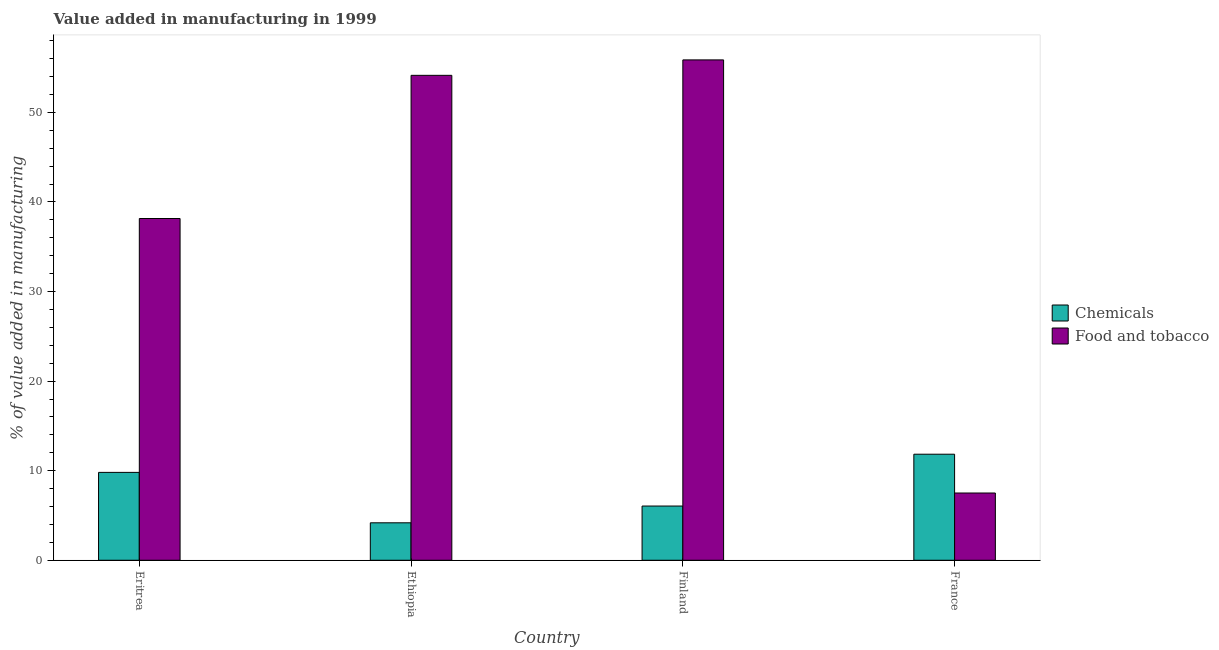What is the value added by manufacturing food and tobacco in France?
Your answer should be compact. 7.51. Across all countries, what is the maximum value added by manufacturing food and tobacco?
Your answer should be compact. 55.86. Across all countries, what is the minimum value added by manufacturing food and tobacco?
Ensure brevity in your answer.  7.51. In which country was the value added by manufacturing food and tobacco minimum?
Offer a very short reply. France. What is the total value added by manufacturing food and tobacco in the graph?
Offer a terse response. 155.66. What is the difference between the value added by manufacturing food and tobacco in Eritrea and that in France?
Offer a terse response. 30.65. What is the difference between the value added by manufacturing food and tobacco in Finland and the value added by  manufacturing chemicals in France?
Give a very brief answer. 44.02. What is the average value added by  manufacturing chemicals per country?
Provide a short and direct response. 7.97. What is the difference between the value added by manufacturing food and tobacco and value added by  manufacturing chemicals in Ethiopia?
Keep it short and to the point. 49.96. In how many countries, is the value added by  manufacturing chemicals greater than 52 %?
Keep it short and to the point. 0. What is the ratio of the value added by manufacturing food and tobacco in Finland to that in France?
Your answer should be compact. 7.44. What is the difference between the highest and the second highest value added by manufacturing food and tobacco?
Keep it short and to the point. 1.72. What is the difference between the highest and the lowest value added by  manufacturing chemicals?
Your answer should be compact. 7.66. Is the sum of the value added by manufacturing food and tobacco in Finland and France greater than the maximum value added by  manufacturing chemicals across all countries?
Your answer should be very brief. Yes. What does the 2nd bar from the left in Finland represents?
Provide a short and direct response. Food and tobacco. What does the 2nd bar from the right in Ethiopia represents?
Offer a very short reply. Chemicals. Are all the bars in the graph horizontal?
Give a very brief answer. No. How many countries are there in the graph?
Your response must be concise. 4. What is the difference between two consecutive major ticks on the Y-axis?
Provide a short and direct response. 10. Are the values on the major ticks of Y-axis written in scientific E-notation?
Offer a very short reply. No. Does the graph contain grids?
Keep it short and to the point. No. Where does the legend appear in the graph?
Your answer should be very brief. Center right. How are the legend labels stacked?
Your answer should be compact. Vertical. What is the title of the graph?
Your answer should be compact. Value added in manufacturing in 1999. What is the label or title of the Y-axis?
Your answer should be compact. % of value added in manufacturing. What is the % of value added in manufacturing in Chemicals in Eritrea?
Ensure brevity in your answer.  9.81. What is the % of value added in manufacturing of Food and tobacco in Eritrea?
Ensure brevity in your answer.  38.15. What is the % of value added in manufacturing in Chemicals in Ethiopia?
Ensure brevity in your answer.  4.18. What is the % of value added in manufacturing of Food and tobacco in Ethiopia?
Offer a terse response. 54.14. What is the % of value added in manufacturing of Chemicals in Finland?
Your response must be concise. 6.05. What is the % of value added in manufacturing in Food and tobacco in Finland?
Provide a succinct answer. 55.86. What is the % of value added in manufacturing in Chemicals in France?
Provide a succinct answer. 11.84. What is the % of value added in manufacturing of Food and tobacco in France?
Provide a succinct answer. 7.51. Across all countries, what is the maximum % of value added in manufacturing of Chemicals?
Offer a very short reply. 11.84. Across all countries, what is the maximum % of value added in manufacturing in Food and tobacco?
Your response must be concise. 55.86. Across all countries, what is the minimum % of value added in manufacturing of Chemicals?
Provide a succinct answer. 4.18. Across all countries, what is the minimum % of value added in manufacturing in Food and tobacco?
Offer a very short reply. 7.51. What is the total % of value added in manufacturing of Chemicals in the graph?
Your answer should be compact. 31.89. What is the total % of value added in manufacturing in Food and tobacco in the graph?
Your answer should be very brief. 155.66. What is the difference between the % of value added in manufacturing in Chemicals in Eritrea and that in Ethiopia?
Your answer should be compact. 5.63. What is the difference between the % of value added in manufacturing of Food and tobacco in Eritrea and that in Ethiopia?
Provide a short and direct response. -15.98. What is the difference between the % of value added in manufacturing of Chemicals in Eritrea and that in Finland?
Your answer should be compact. 3.76. What is the difference between the % of value added in manufacturing in Food and tobacco in Eritrea and that in Finland?
Provide a short and direct response. -17.71. What is the difference between the % of value added in manufacturing in Chemicals in Eritrea and that in France?
Make the answer very short. -2.03. What is the difference between the % of value added in manufacturing in Food and tobacco in Eritrea and that in France?
Keep it short and to the point. 30.65. What is the difference between the % of value added in manufacturing of Chemicals in Ethiopia and that in Finland?
Offer a terse response. -1.87. What is the difference between the % of value added in manufacturing of Food and tobacco in Ethiopia and that in Finland?
Your response must be concise. -1.72. What is the difference between the % of value added in manufacturing of Chemicals in Ethiopia and that in France?
Provide a short and direct response. -7.66. What is the difference between the % of value added in manufacturing of Food and tobacco in Ethiopia and that in France?
Your answer should be compact. 46.63. What is the difference between the % of value added in manufacturing in Chemicals in Finland and that in France?
Offer a terse response. -5.79. What is the difference between the % of value added in manufacturing in Food and tobacco in Finland and that in France?
Your response must be concise. 48.35. What is the difference between the % of value added in manufacturing of Chemicals in Eritrea and the % of value added in manufacturing of Food and tobacco in Ethiopia?
Offer a terse response. -44.33. What is the difference between the % of value added in manufacturing in Chemicals in Eritrea and the % of value added in manufacturing in Food and tobacco in Finland?
Your response must be concise. -46.05. What is the difference between the % of value added in manufacturing in Chemicals in Eritrea and the % of value added in manufacturing in Food and tobacco in France?
Give a very brief answer. 2.3. What is the difference between the % of value added in manufacturing in Chemicals in Ethiopia and the % of value added in manufacturing in Food and tobacco in Finland?
Give a very brief answer. -51.68. What is the difference between the % of value added in manufacturing of Chemicals in Ethiopia and the % of value added in manufacturing of Food and tobacco in France?
Offer a terse response. -3.33. What is the difference between the % of value added in manufacturing of Chemicals in Finland and the % of value added in manufacturing of Food and tobacco in France?
Provide a succinct answer. -1.45. What is the average % of value added in manufacturing of Chemicals per country?
Make the answer very short. 7.97. What is the average % of value added in manufacturing in Food and tobacco per country?
Your response must be concise. 38.92. What is the difference between the % of value added in manufacturing in Chemicals and % of value added in manufacturing in Food and tobacco in Eritrea?
Provide a short and direct response. -28.34. What is the difference between the % of value added in manufacturing in Chemicals and % of value added in manufacturing in Food and tobacco in Ethiopia?
Give a very brief answer. -49.96. What is the difference between the % of value added in manufacturing of Chemicals and % of value added in manufacturing of Food and tobacco in Finland?
Provide a short and direct response. -49.81. What is the difference between the % of value added in manufacturing of Chemicals and % of value added in manufacturing of Food and tobacco in France?
Give a very brief answer. 4.33. What is the ratio of the % of value added in manufacturing of Chemicals in Eritrea to that in Ethiopia?
Your answer should be compact. 2.35. What is the ratio of the % of value added in manufacturing of Food and tobacco in Eritrea to that in Ethiopia?
Ensure brevity in your answer.  0.7. What is the ratio of the % of value added in manufacturing in Chemicals in Eritrea to that in Finland?
Provide a succinct answer. 1.62. What is the ratio of the % of value added in manufacturing of Food and tobacco in Eritrea to that in Finland?
Make the answer very short. 0.68. What is the ratio of the % of value added in manufacturing of Chemicals in Eritrea to that in France?
Your answer should be very brief. 0.83. What is the ratio of the % of value added in manufacturing in Food and tobacco in Eritrea to that in France?
Your answer should be very brief. 5.08. What is the ratio of the % of value added in manufacturing in Chemicals in Ethiopia to that in Finland?
Your response must be concise. 0.69. What is the ratio of the % of value added in manufacturing of Food and tobacco in Ethiopia to that in Finland?
Ensure brevity in your answer.  0.97. What is the ratio of the % of value added in manufacturing of Chemicals in Ethiopia to that in France?
Provide a short and direct response. 0.35. What is the ratio of the % of value added in manufacturing of Food and tobacco in Ethiopia to that in France?
Your response must be concise. 7.21. What is the ratio of the % of value added in manufacturing in Chemicals in Finland to that in France?
Offer a very short reply. 0.51. What is the ratio of the % of value added in manufacturing of Food and tobacco in Finland to that in France?
Your answer should be compact. 7.44. What is the difference between the highest and the second highest % of value added in manufacturing of Chemicals?
Offer a very short reply. 2.03. What is the difference between the highest and the second highest % of value added in manufacturing in Food and tobacco?
Your response must be concise. 1.72. What is the difference between the highest and the lowest % of value added in manufacturing in Chemicals?
Offer a very short reply. 7.66. What is the difference between the highest and the lowest % of value added in manufacturing of Food and tobacco?
Your answer should be very brief. 48.35. 